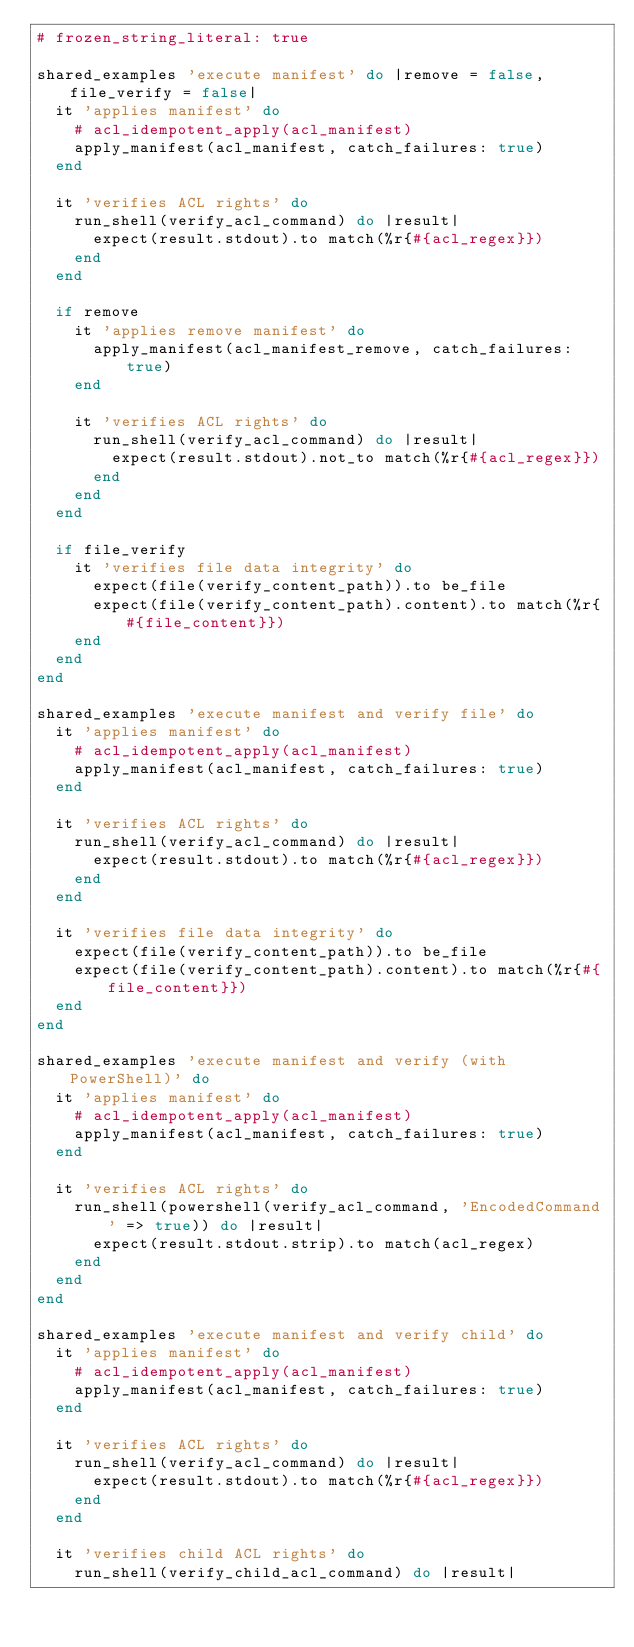<code> <loc_0><loc_0><loc_500><loc_500><_Ruby_># frozen_string_literal: true

shared_examples 'execute manifest' do |remove = false, file_verify = false|
  it 'applies manifest' do
    # acl_idempotent_apply(acl_manifest)
    apply_manifest(acl_manifest, catch_failures: true)
  end

  it 'verifies ACL rights' do
    run_shell(verify_acl_command) do |result|
      expect(result.stdout).to match(%r{#{acl_regex}})
    end
  end

  if remove
    it 'applies remove manifest' do
      apply_manifest(acl_manifest_remove, catch_failures: true)
    end

    it 'verifies ACL rights' do
      run_shell(verify_acl_command) do |result|
        expect(result.stdout).not_to match(%r{#{acl_regex}})
      end
    end
  end

  if file_verify
    it 'verifies file data integrity' do
      expect(file(verify_content_path)).to be_file
      expect(file(verify_content_path).content).to match(%r{#{file_content}})
    end
  end
end

shared_examples 'execute manifest and verify file' do
  it 'applies manifest' do
    # acl_idempotent_apply(acl_manifest)
    apply_manifest(acl_manifest, catch_failures: true)
  end

  it 'verifies ACL rights' do
    run_shell(verify_acl_command) do |result|
      expect(result.stdout).to match(%r{#{acl_regex}})
    end
  end

  it 'verifies file data integrity' do
    expect(file(verify_content_path)).to be_file
    expect(file(verify_content_path).content).to match(%r{#{file_content}})
  end
end

shared_examples 'execute manifest and verify (with PowerShell)' do
  it 'applies manifest' do
    # acl_idempotent_apply(acl_manifest)
    apply_manifest(acl_manifest, catch_failures: true)
  end

  it 'verifies ACL rights' do
    run_shell(powershell(verify_acl_command, 'EncodedCommand' => true)) do |result|
      expect(result.stdout.strip).to match(acl_regex)
    end
  end
end

shared_examples 'execute manifest and verify child' do
  it 'applies manifest' do
    # acl_idempotent_apply(acl_manifest)
    apply_manifest(acl_manifest, catch_failures: true)
  end

  it 'verifies ACL rights' do
    run_shell(verify_acl_command) do |result|
      expect(result.stdout).to match(%r{#{acl_regex}})
    end
  end

  it 'verifies child ACL rights' do
    run_shell(verify_child_acl_command) do |result|</code> 